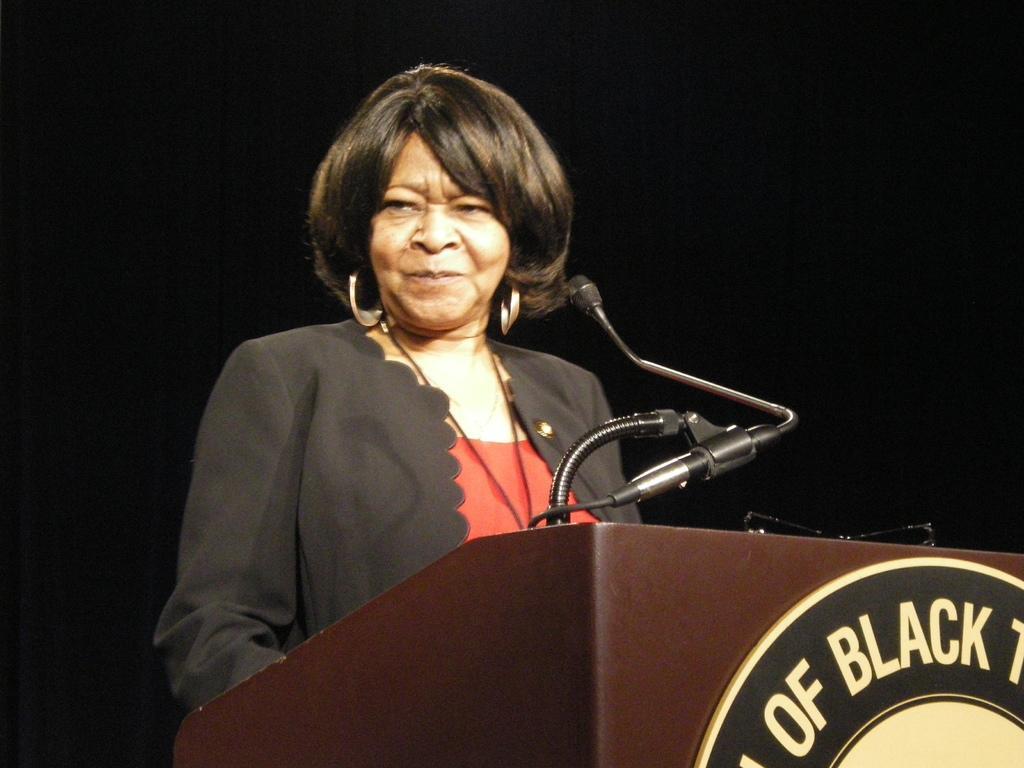In one or two sentences, can you explain what this image depicts? In this image I can see the person standing in-front of the podium. On the podium I can see the mic. The person wearing the red and black color dress. And there is a black background. 